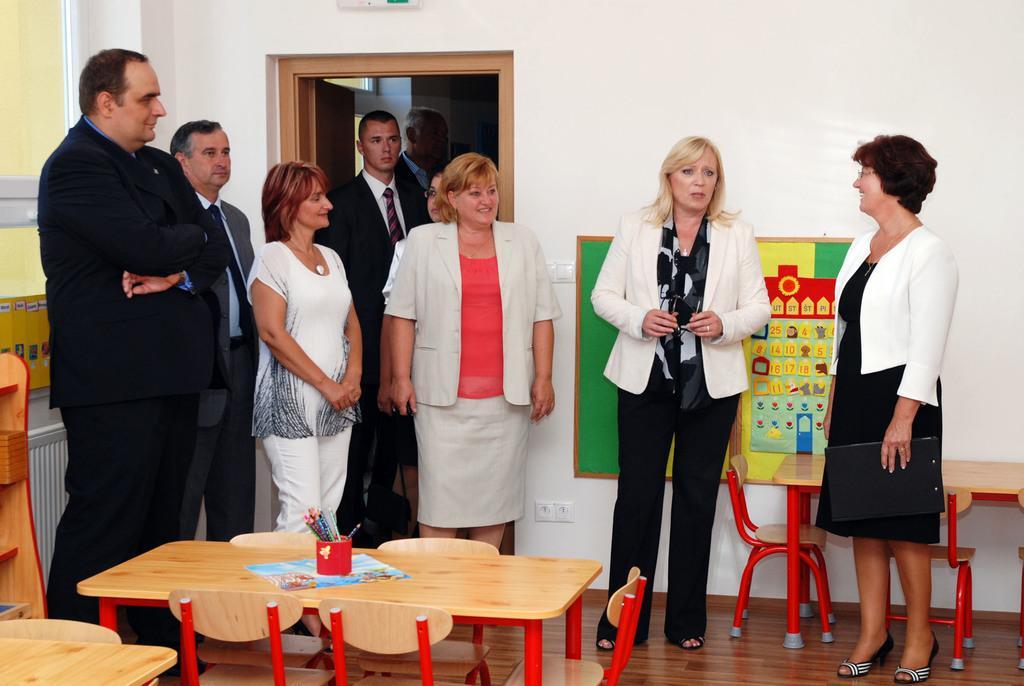Please provide a concise description of this image. In this image i can see group of people standing there are few pens on a table, a chair at the back ground i can see a wall and a door. 